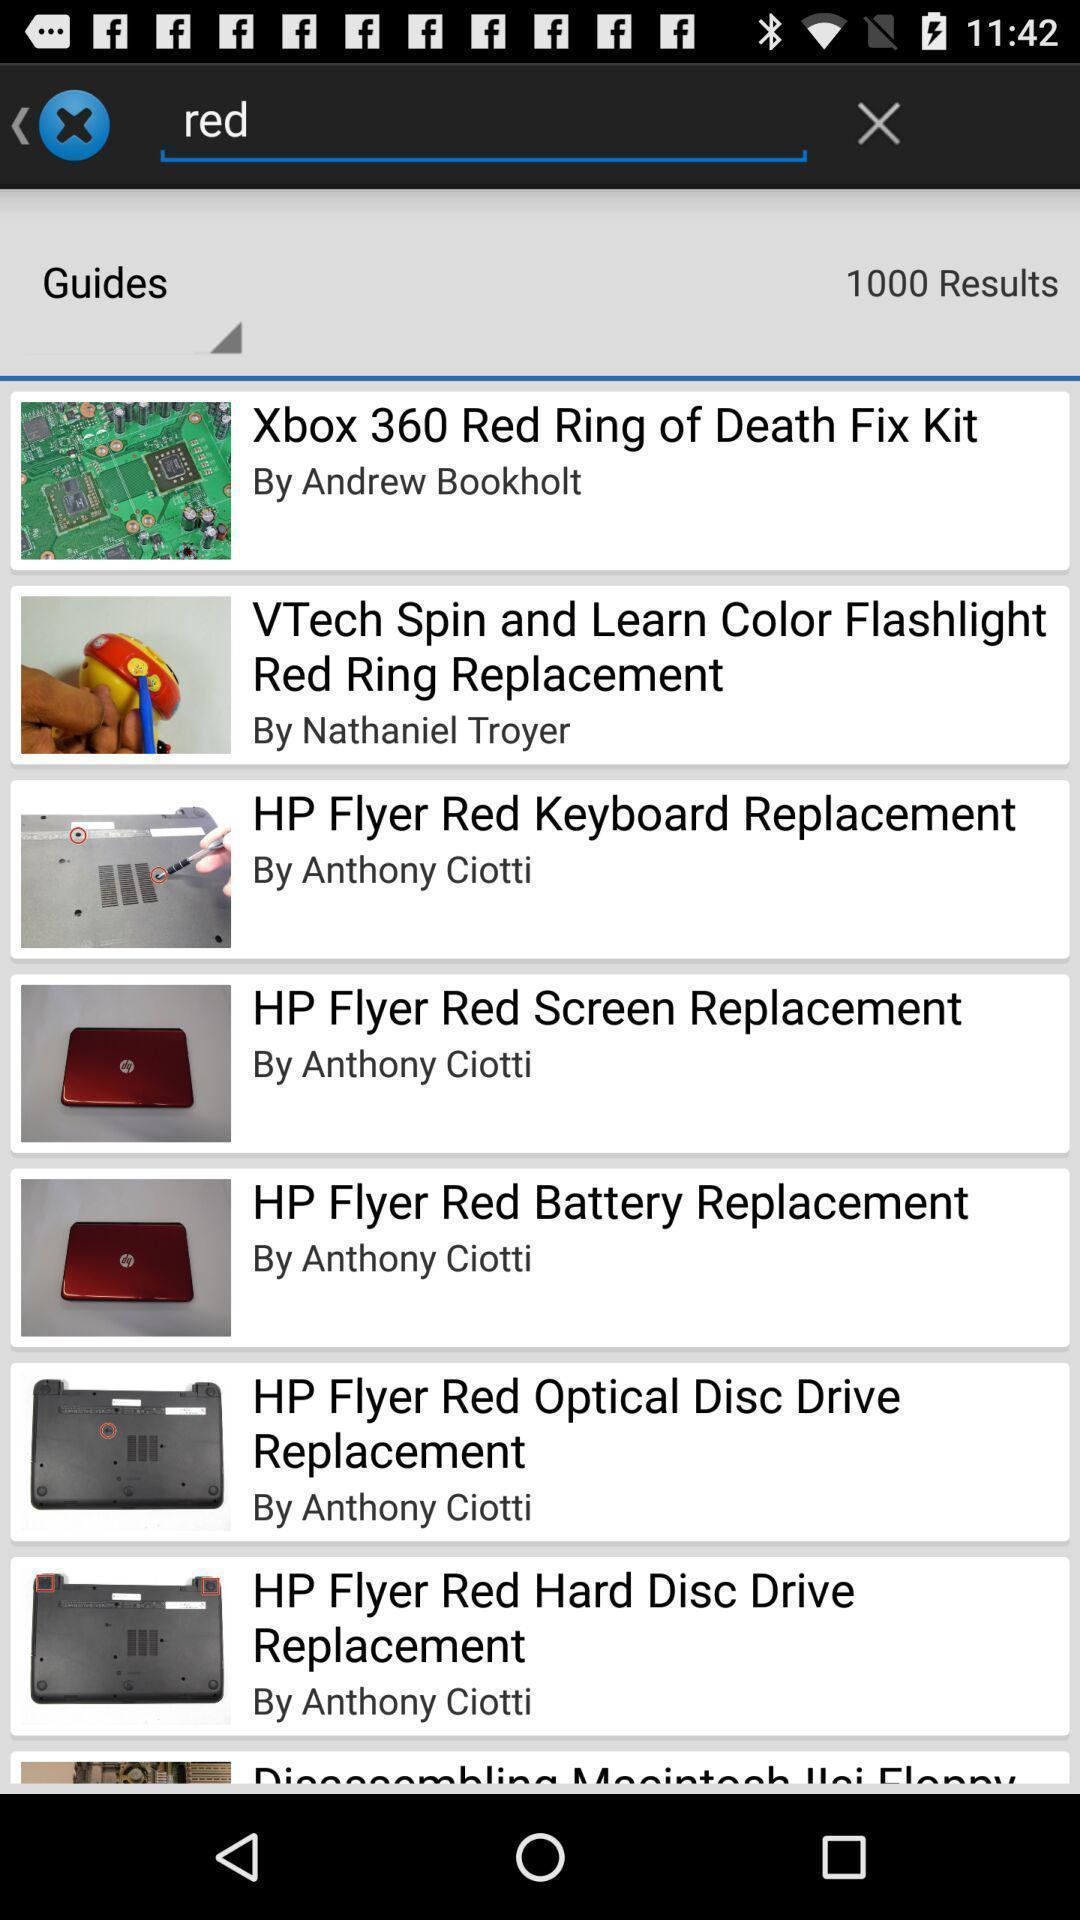What can you discern from this picture? Search option to find different electronic items. 